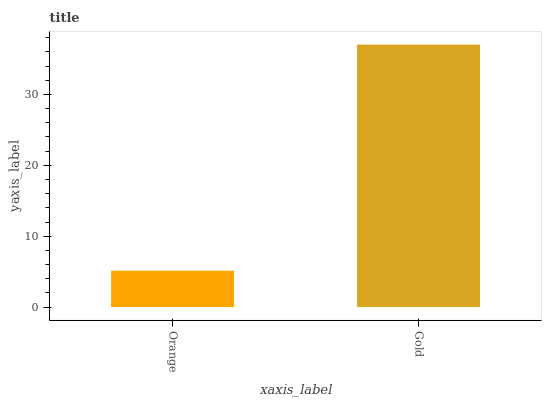Is Orange the minimum?
Answer yes or no. Yes. Is Gold the maximum?
Answer yes or no. Yes. Is Gold the minimum?
Answer yes or no. No. Is Gold greater than Orange?
Answer yes or no. Yes. Is Orange less than Gold?
Answer yes or no. Yes. Is Orange greater than Gold?
Answer yes or no. No. Is Gold less than Orange?
Answer yes or no. No. Is Gold the high median?
Answer yes or no. Yes. Is Orange the low median?
Answer yes or no. Yes. Is Orange the high median?
Answer yes or no. No. Is Gold the low median?
Answer yes or no. No. 